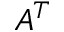Convert formula to latex. <formula><loc_0><loc_0><loc_500><loc_500>A ^ { T }</formula> 